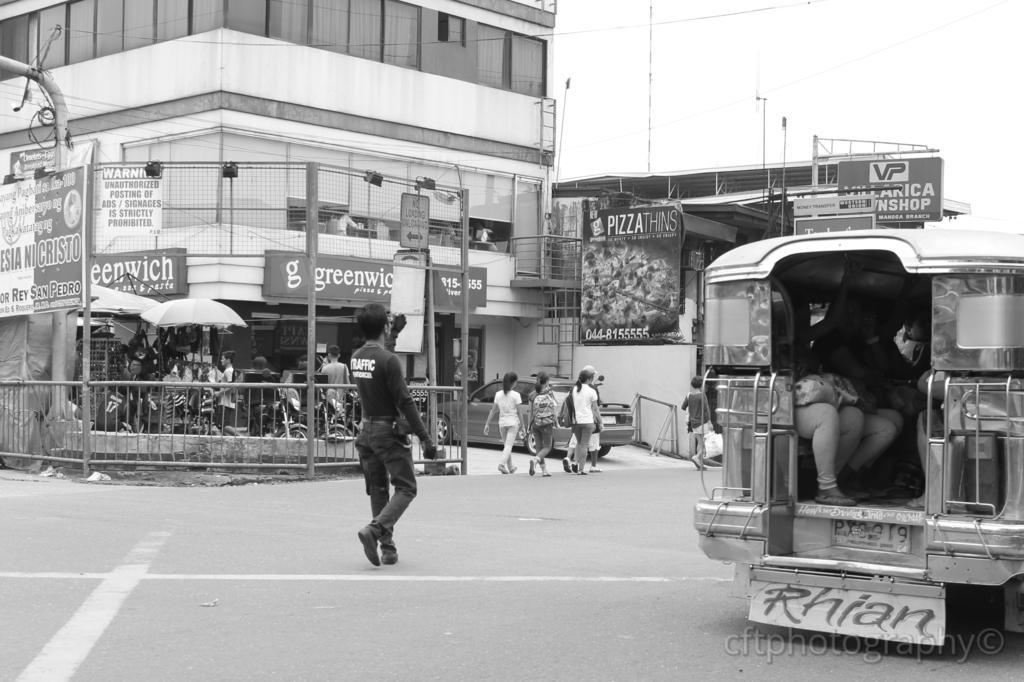Can you describe this image briefly? This image consists of many people. To the right, there is a vehicle in which there are many persons sitting. At the bottom, there is a road. In the background, there are buildings along with boards and banners. 